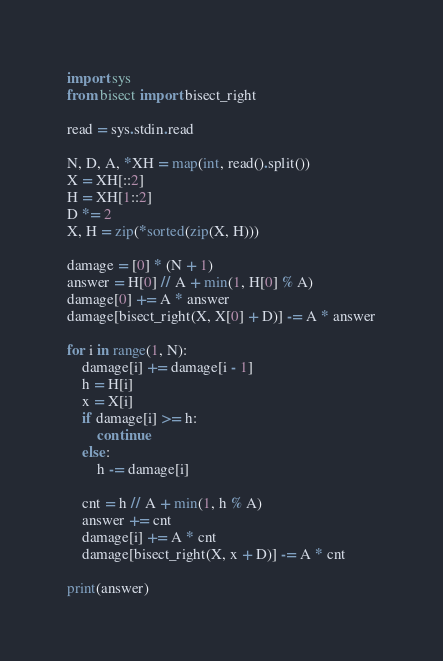<code> <loc_0><loc_0><loc_500><loc_500><_Python_>import sys
from bisect import bisect_right

read = sys.stdin.read

N, D, A, *XH = map(int, read().split())
X = XH[::2]
H = XH[1::2]
D *= 2
X, H = zip(*sorted(zip(X, H)))

damage = [0] * (N + 1)
answer = H[0] // A + min(1, H[0] % A)
damage[0] += A * answer
damage[bisect_right(X, X[0] + D)] -= A * answer

for i in range(1, N):
    damage[i] += damage[i - 1]
    h = H[i]
    x = X[i]
    if damage[i] >= h:
        continue
    else:
        h -= damage[i]

    cnt = h // A + min(1, h % A)
    answer += cnt
    damage[i] += A * cnt
    damage[bisect_right(X, x + D)] -= A * cnt

print(answer)
</code> 